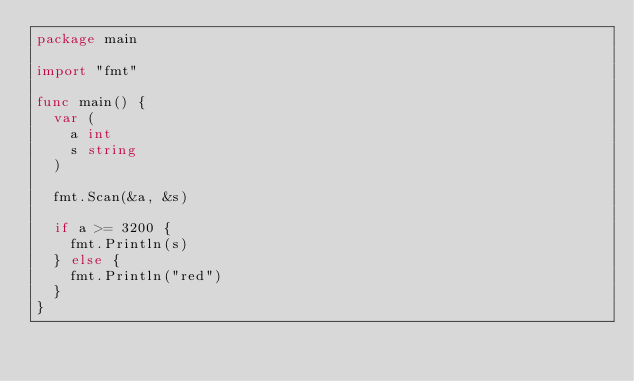<code> <loc_0><loc_0><loc_500><loc_500><_Go_>package main

import "fmt"

func main() {
	var (
		a int
		s string
	)

	fmt.Scan(&a, &s)

	if a >= 3200 {
		fmt.Println(s)
	} else {
		fmt.Println("red")
	}
}
</code> 